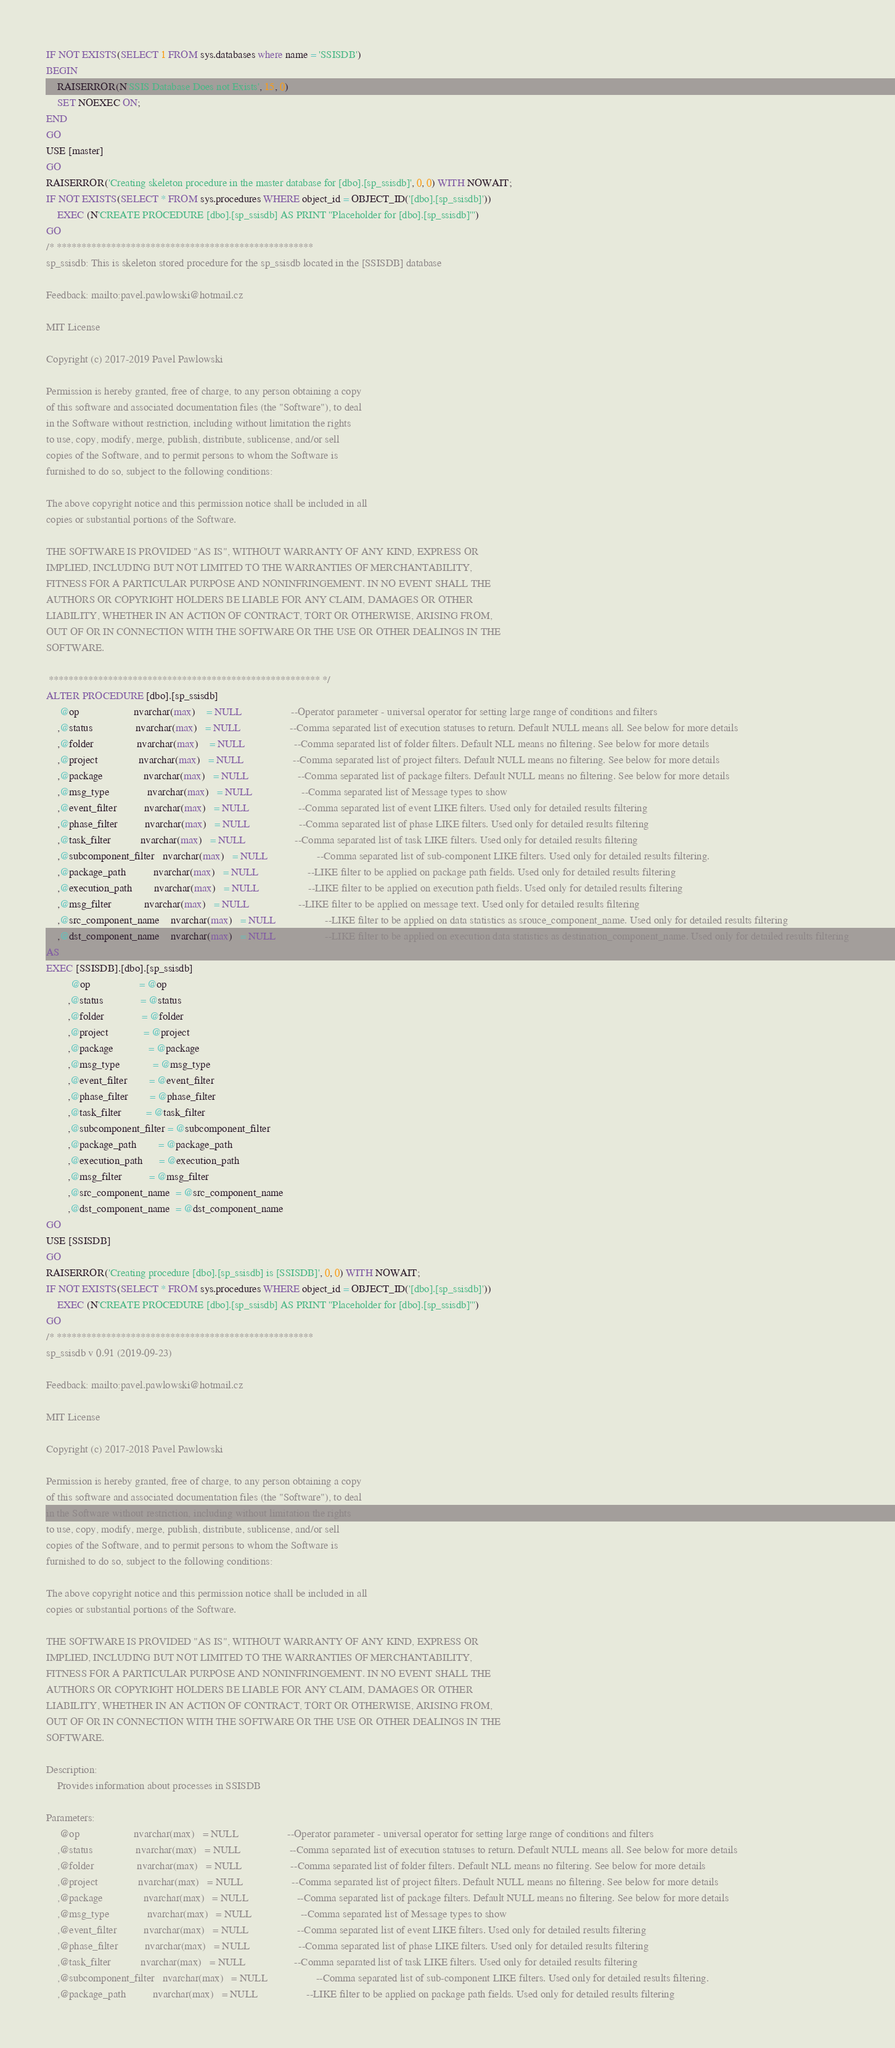<code> <loc_0><loc_0><loc_500><loc_500><_SQL_>IF NOT EXISTS(SELECT 1 FROM sys.databases where name = 'SSISDB')
BEGIN
    RAISERROR(N'SSIS Database Does not Exists', 15, 0)
    SET NOEXEC ON;
END
GO
USE [master]
GO
RAISERROR('Creating skeleton procedure in the master database for [dbo].[sp_ssisdb]', 0, 0) WITH NOWAIT;
IF NOT EXISTS(SELECT * FROM sys.procedures WHERE object_id = OBJECT_ID('[dbo].[sp_ssisdb]'))
    EXEC (N'CREATE PROCEDURE [dbo].[sp_ssisdb] AS PRINT ''Placeholder for [dbo].[sp_ssisdb]''')
GO
/* ****************************************************
sp_ssisdb: This is skeleton stored procedure for the sp_ssisdb located in the [SSISDB] database

Feedback: mailto:pavel.pawlowski@hotmail.cz

MIT License

Copyright (c) 2017-2019 Pavel Pawlowski

Permission is hereby granted, free of charge, to any person obtaining a copy
of this software and associated documentation files (the "Software"), to deal
in the Software without restriction, including without limitation the rights
to use, copy, modify, merge, publish, distribute, sublicense, and/or sell
copies of the Software, and to permit persons to whom the Software is
furnished to do so, subject to the following conditions:

The above copyright notice and this permission notice shall be included in all
copies or substantial portions of the Software.

THE SOFTWARE IS PROVIDED "AS IS", WITHOUT WARRANTY OF ANY KIND, EXPRESS OR
IMPLIED, INCLUDING BUT NOT LIMITED TO THE WARRANTIES OF MERCHANTABILITY,
FITNESS FOR A PARTICULAR PURPOSE AND NONINFRINGEMENT. IN NO EVENT SHALL THE
AUTHORS OR COPYRIGHT HOLDERS BE LIABLE FOR ANY CLAIM, DAMAGES OR OTHER
LIABILITY, WHETHER IN AN ACTION OF CONTRACT, TORT OR OTHERWISE, ARISING FROM,
OUT OF OR IN CONNECTION WITH THE SOFTWARE OR THE USE OR OTHER DEALINGS IN THE
SOFTWARE.

 ******************************************************* */
ALTER PROCEDURE [dbo].[sp_ssisdb]
     @op                    nvarchar(max)	= NULL                  --Operator parameter - universal operator for setting large range of conditions and filters
    ,@status                nvarchar(max)   = NULL                  --Comma separated list of execution statuses to return. Default NULL means all. See below for more details
    ,@folder                nvarchar(max)	= NULL                  --Comma separated list of folder filters. Default NLL means no filtering. See below for more details
    ,@project               nvarchar(max)   = NULL                  --Comma separated list of project filters. Default NULL means no filtering. See below for more details
    ,@package               nvarchar(max)   = NULL                  --Comma separated list of package filters. Default NULL means no filtering. See below for more details
    ,@msg_type              nvarchar(max)   = NULL                  --Comma separated list of Message types to show
    ,@event_filter          nvarchar(max)   = NULL                  --Comma separated list of event LIKE filters. Used only for detailed results filtering
    ,@phase_filter          nvarchar(max)   = NULL                  --Comma separated list of phase LIKE filters. Used only for detailed results filtering
    ,@task_filter           nvarchar(max)   = NULL                  --Comma separated list of task LIKE filters. Used only for detailed results filtering
    ,@subcomponent_filter   nvarchar(max)   = NULL                  --Comma separated list of sub-component LIKE filters. Used only for detailed results filtering.
    ,@package_path          nvarchar(max)   = NULL                  --LIKE filter to be applied on package path fields. Used only for detailed results filtering
    ,@execution_path        nvarchar(max)   = NULL                  --LIKE filter to be applied on execution path fields. Used only for detailed results filtering
    ,@msg_filter            nvarchar(max)   = NULL                  --LIKE filter to be applied on message text. Used only for detailed results filtering
    ,@src_component_name    nvarchar(max)   = NULL                  --LIKE filter to be applied on data statistics as srouce_component_name. Used only for detailed results filtering
    ,@dst_component_name    nvarchar(max)   = NULL                  --LIKE filter to be applied on execution data statistics as destination_component_name. Used only for detailed results filtering
AS
EXEC [SSISDB].[dbo].[sp_ssisdb]
         @op                  = @op                 
        ,@status              = @status             
        ,@folder              = @folder             
        ,@project             = @project            
        ,@package             = @package            
        ,@msg_type            = @msg_type           
        ,@event_filter        = @event_filter       
        ,@phase_filter        = @phase_filter       
        ,@task_filter         = @task_filter        
        ,@subcomponent_filter = @subcomponent_filter
        ,@package_path        = @package_path       
        ,@execution_path      = @execution_path     
        ,@msg_filter          = @msg_filter         
        ,@src_component_name  = @src_component_name 
        ,@dst_component_name  = @dst_component_name 
GO
USE [SSISDB]
GO
RAISERROR('Creating procedure [dbo].[sp_ssisdb] is [SSISDB]', 0, 0) WITH NOWAIT;
IF NOT EXISTS(SELECT * FROM sys.procedures WHERE object_id = OBJECT_ID('[dbo].[sp_ssisdb]'))
    EXEC (N'CREATE PROCEDURE [dbo].[sp_ssisdb] AS PRINT ''Placeholder for [dbo].[sp_ssisdb]''')
GO
/* ****************************************************
sp_ssisdb v 0.91 (2019-09-23)

Feedback: mailto:pavel.pawlowski@hotmail.cz

MIT License

Copyright (c) 2017-2018 Pavel Pawlowski

Permission is hereby granted, free of charge, to any person obtaining a copy
of this software and associated documentation files (the "Software"), to deal
in the Software without restriction, including without limitation the rights
to use, copy, modify, merge, publish, distribute, sublicense, and/or sell
copies of the Software, and to permit persons to whom the Software is
furnished to do so, subject to the following conditions:

The above copyright notice and this permission notice shall be included in all
copies or substantial portions of the Software.

THE SOFTWARE IS PROVIDED "AS IS", WITHOUT WARRANTY OF ANY KIND, EXPRESS OR
IMPLIED, INCLUDING BUT NOT LIMITED TO THE WARRANTIES OF MERCHANTABILITY,
FITNESS FOR A PARTICULAR PURPOSE AND NONINFRINGEMENT. IN NO EVENT SHALL THE
AUTHORS OR COPYRIGHT HOLDERS BE LIABLE FOR ANY CLAIM, DAMAGES OR OTHER
LIABILITY, WHETHER IN AN ACTION OF CONTRACT, TORT OR OTHERWISE, ARISING FROM,
OUT OF OR IN CONNECTION WITH THE SOFTWARE OR THE USE OR OTHER DEALINGS IN THE
SOFTWARE.

Description:
    Provides information about processes in SSISDB

Parameters:
     @op                    nvarchar(max)	= NULL                  --Operator parameter - universal operator for setting large range of conditions and filters
    ,@status                nvarchar(max)   = NULL                  --Comma separated list of execution statuses to return. Default NULL means all. See below for more details
    ,@folder                nvarchar(max)	= NULL                  --Comma separated list of folder filters. Default NLL means no filtering. See below for more details
    ,@project               nvarchar(max)   = NULL                  --Comma separated list of project filters. Default NULL means no filtering. See below for more details
    ,@package               nvarchar(max)   = NULL                  --Comma separated list of package filters. Default NULL means no filtering. See below for more details
    ,@msg_type              nvarchar(max)   = NULL                  --Comma separated list of Message types to show
    ,@event_filter          nvarchar(max)   = NULL                  --Comma separated list of event LIKE filters. Used only for detailed results filtering
    ,@phase_filter          nvarchar(max)   = NULL                  --Comma separated list of phase LIKE filters. Used only for detailed results filtering
    ,@task_filter           nvarchar(max)   = NULL                  --Comma separated list of task LIKE filters. Used only for detailed results filtering
    ,@subcomponent_filter   nvarchar(max)   = NULL                  --Comma separated list of sub-component LIKE filters. Used only for detailed results filtering.
    ,@package_path          nvarchar(max)   = NULL                  --LIKE filter to be applied on package path fields. Used only for detailed results filtering</code> 